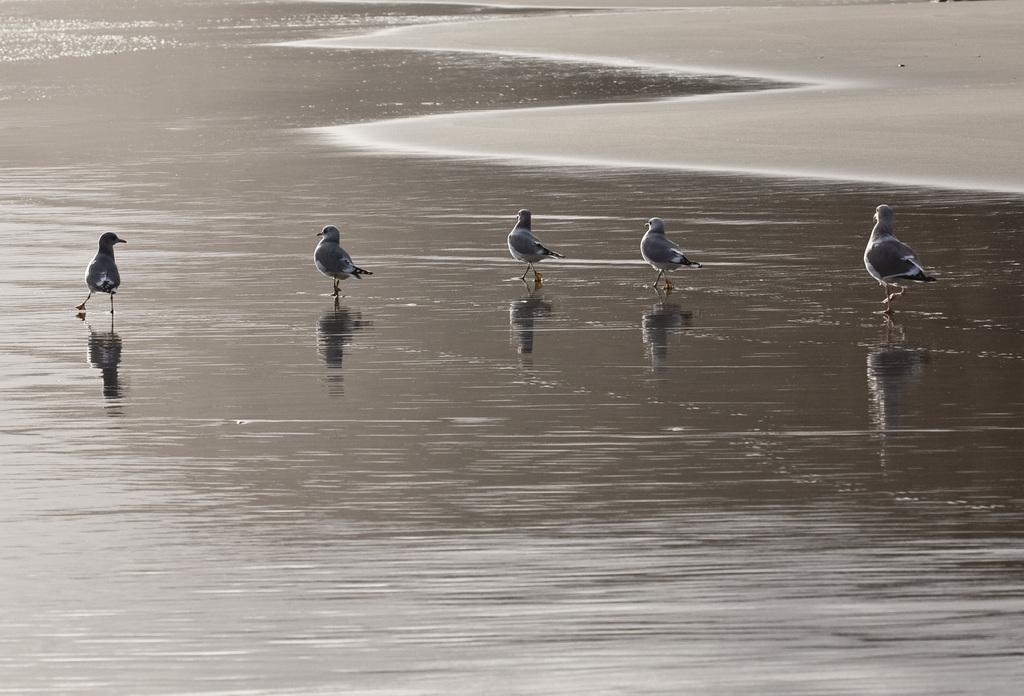What type of animals can be seen in the image? Birds can be seen in the water. What is visible at the top of the image? There is sand visible at the top of the image. What can be observed about the birds' reflections on the water? The reflections of the birds are visible on the water. What type of knowledge is being shared during the meeting in the image? There is no meeting present in the image, so it is not possible to determine what type of knowledge might be shared. 